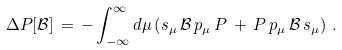Convert formula to latex. <formula><loc_0><loc_0><loc_500><loc_500>\Delta P [ { \mathcal { B } } ] \, = \, - \int _ { - \infty } ^ { \infty } d \mu \left ( s _ { \mu } \, { \mathcal { B } } \, p _ { \mu } \, P \, + \, P \, p _ { \mu } \, { \mathcal { B } } \, s _ { \mu } \right ) \, .</formula> 